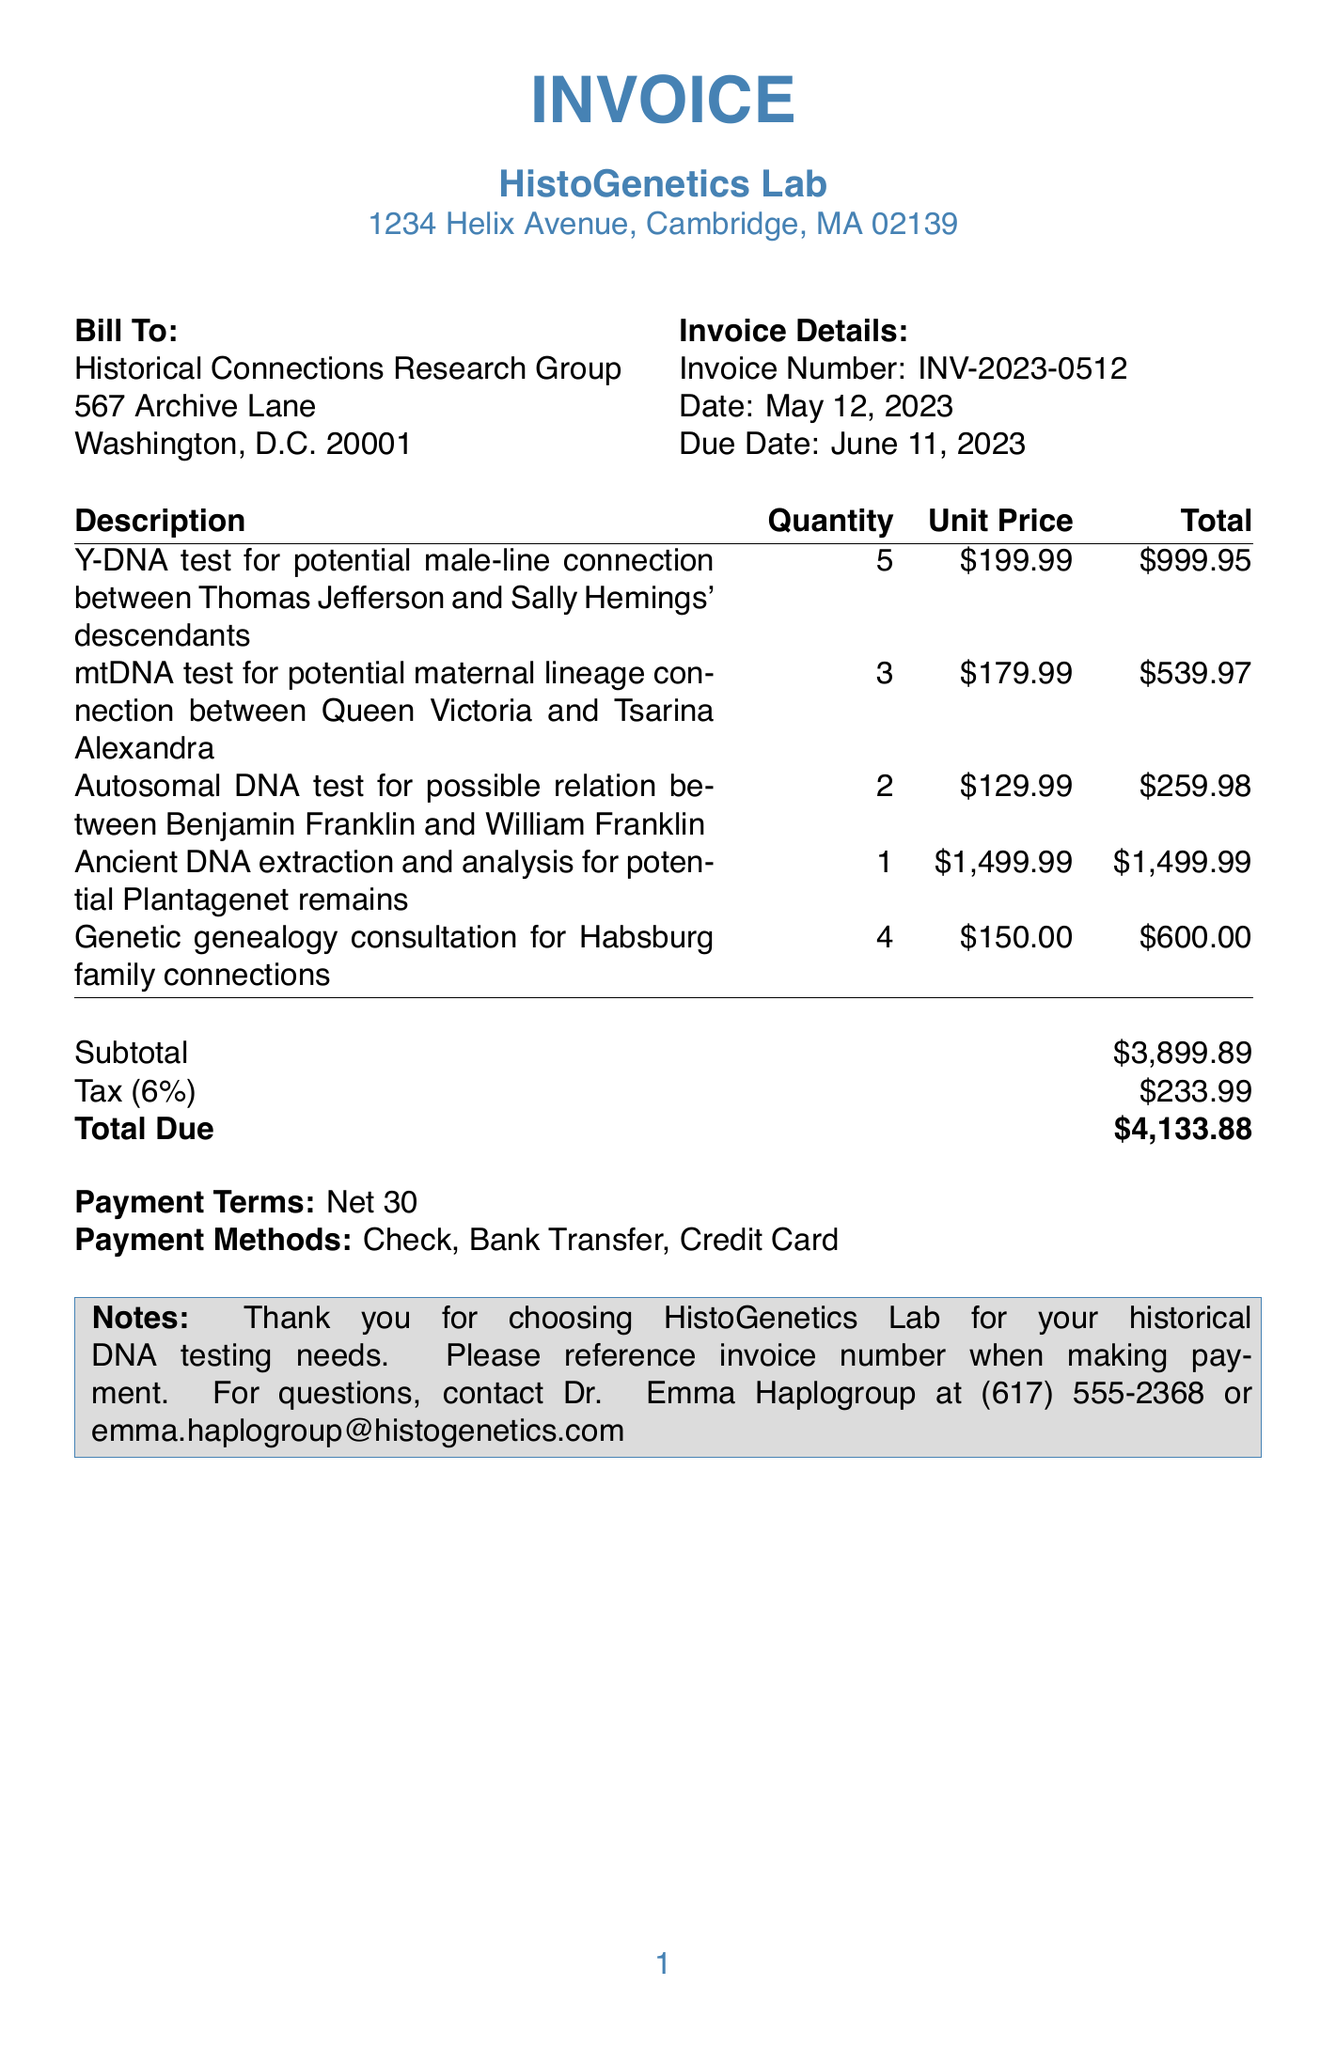What is the invoice number? The invoice number is clearly stated in the document, specifically in the Invoice Details section.
Answer: INV-2023-0512 Who is the client? The client is mentioned at the beginning of the document under the Bill To section.
Answer: Historical Connections Research Group What is the date of the invoice? The date of the invoice is provided in the Invoice Details section.
Answer: May 12, 2023 How many Y-DNA tests were included in the invoice? The quantity of Y-DNA tests can be found in the table where the items are listed.
Answer: 5 What is the total amount due on the invoice? The total amount due is presented at the end of the invoice, summarizing the subtotal, tax, and final amount.
Answer: $4,133.88 What type of DNA test is being performed for Benjamin Franklin? The document lists the description of the test in the items section, indicating the specific type of test being conducted.
Answer: Autosomal DNA test What is the tax rate applied to the invoice? The tax rate is specifically mentioned in the summary table of the invoice.
Answer: 6% What contact information is provided for questions about the invoice? The document includes contact information in the notes section, which is relevant for further inquiries.
Answer: Dr. Emma Haplogroup at (617) 555-2368 or emma.haplogroup@histogenetics.com What payment terms are specified in the invoice? The payment terms are detailed in the invoice and indicate when payment is expected.
Answer: Net 30 